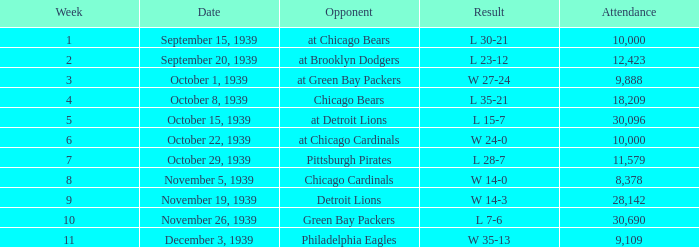Which Attendance has an Opponent of green bay packers, and a Week larger than 10? None. 